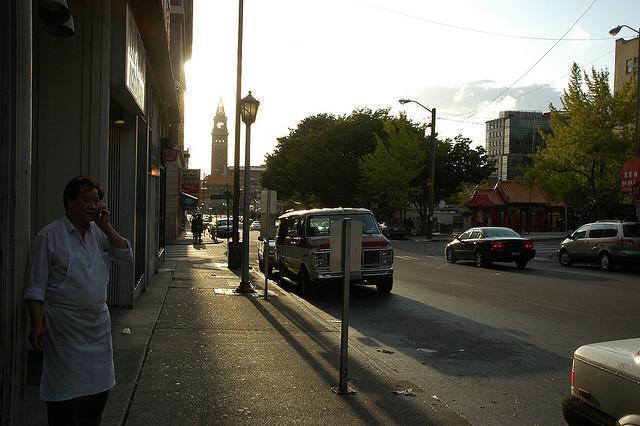What is the man in white apron holding to his ear?
Pick the correct solution from the four options below to address the question.
Options: Cellphone, banana, bean bag, ice pack. Cellphone. 